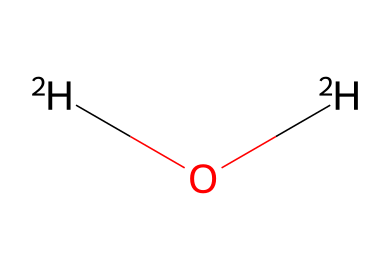What is the name of this chemical? The SMILES notation indicates the presence of deuterium (represented as [2H]) combined with oxygen (O). This combination forms heavy water, which is the common name used to describe deuterium oxide.
Answer: heavy water How many hydrogen atoms are in this molecule? The SMILES representation shows two instances of [2H], indicating there are two hydrogen atoms present in the molecule.
Answer: 2 What type of bonds are present in this molecule? The chemical structure indicates that both hydrogen atoms are covalently bonded to the oxygen atom because these types of bonds are typical in water and its isotopes.
Answer: covalent What is the molecular formula of this chemical? The chemical structure shows 2 hydrogen atoms ([2H]) and 1 oxygen atom, which corresponds to the molecular formula D2O for deuterium oxide.
Answer: D2O Why is deuterium oxide used in nuclear research? Deuterium oxide is used in nuclear research mainly because its neutron-rich nature (due to deuterium) slows down neutrons effectively, making it suitable as a moderator in nuclear reactors.
Answer: slows neutrons How does deuterium differ from regular hydrogen? Deuterium contains one neutron in addition to one proton, while regular hydrogen (protium) contains only one proton and no neutrons, making deuterium heavier.
Answer: heavier In what state is deuterium oxide at room temperature? Deuterium oxide is a liquid at room temperature, similar to regular water due to its similar physical properties.
Answer: liquid 